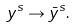<formula> <loc_0><loc_0><loc_500><loc_500>y ^ { s } \to \bar { y } ^ { s } .</formula> 